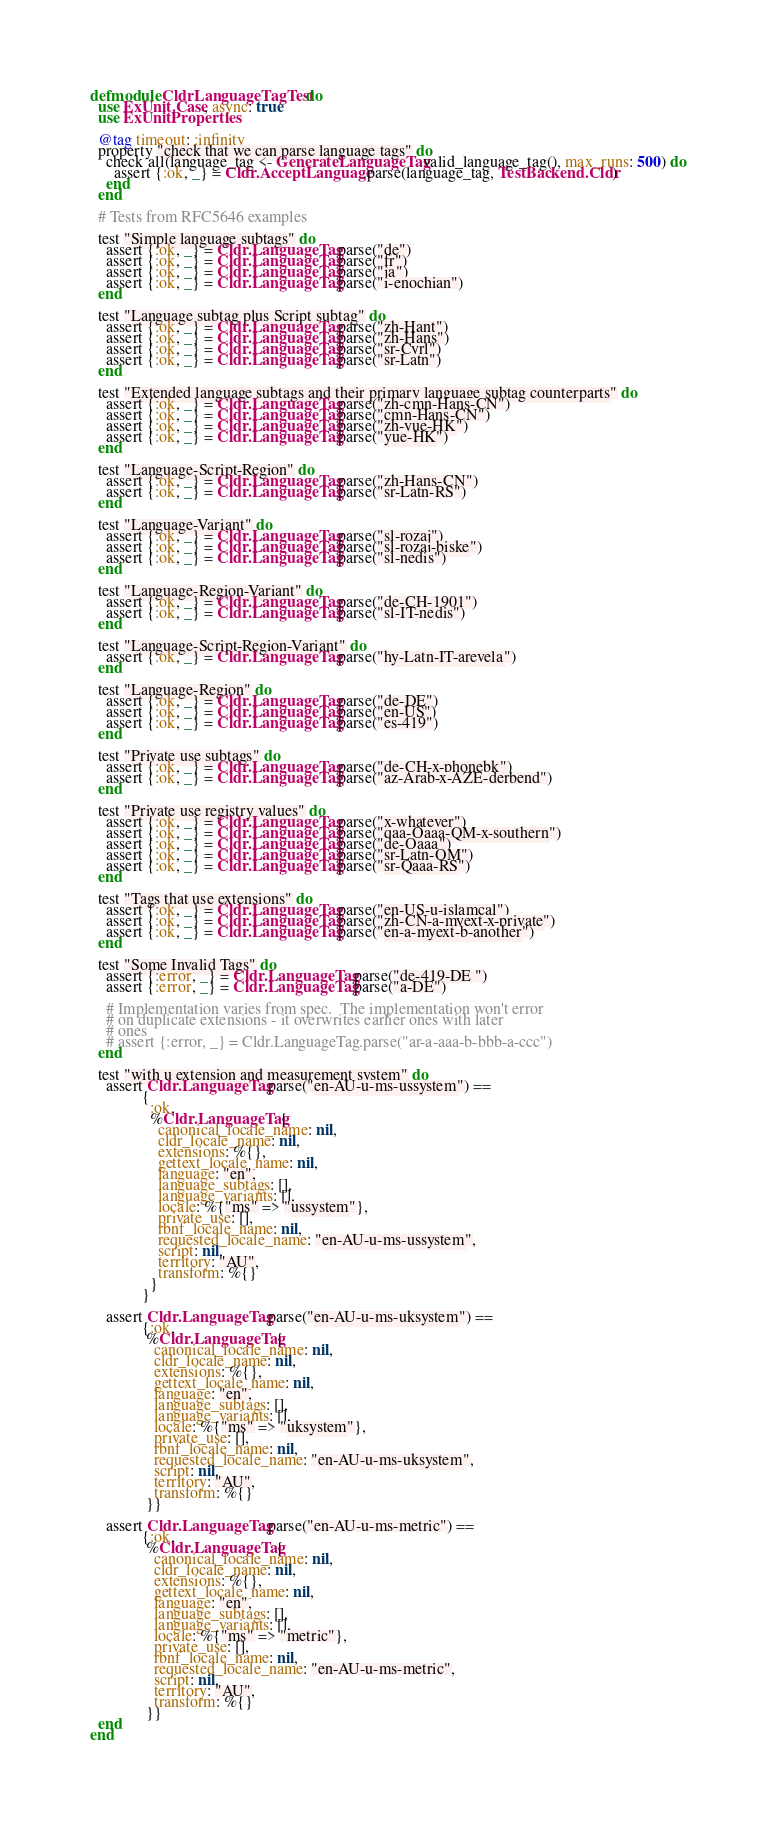<code> <loc_0><loc_0><loc_500><loc_500><_Elixir_>defmodule CldrLanguageTagTest do
  use ExUnit.Case, async: true
  use ExUnitProperties

  @tag timeout: :infinity
  property "check that we can parse language tags" do
    check all(language_tag <- GenerateLanguageTag.valid_language_tag(), max_runs: 500) do
      assert {:ok, _} = Cldr.AcceptLanguage.parse(language_tag, TestBackend.Cldr)
    end
  end

  # Tests from RFC5646 examples

  test "Simple language subtags" do
    assert {:ok, _} = Cldr.LanguageTag.parse("de")
    assert {:ok, _} = Cldr.LanguageTag.parse("fr")
    assert {:ok, _} = Cldr.LanguageTag.parse("ja")
    assert {:ok, _} = Cldr.LanguageTag.parse("i-enochian")
  end

  test "Language subtag plus Script subtag" do
    assert {:ok, _} = Cldr.LanguageTag.parse("zh-Hant")
    assert {:ok, _} = Cldr.LanguageTag.parse("zh-Hans")
    assert {:ok, _} = Cldr.LanguageTag.parse("sr-Cyrl")
    assert {:ok, _} = Cldr.LanguageTag.parse("sr-Latn")
  end

  test "Extended language subtags and their primary language subtag counterparts" do
    assert {:ok, _} = Cldr.LanguageTag.parse("zh-cmn-Hans-CN")
    assert {:ok, _} = Cldr.LanguageTag.parse("cmn-Hans-CN")
    assert {:ok, _} = Cldr.LanguageTag.parse("zh-yue-HK")
    assert {:ok, _} = Cldr.LanguageTag.parse("yue-HK")
  end

  test "Language-Script-Region" do
    assert {:ok, _} = Cldr.LanguageTag.parse("zh-Hans-CN")
    assert {:ok, _} = Cldr.LanguageTag.parse("sr-Latn-RS")
  end

  test "Language-Variant" do
    assert {:ok, _} = Cldr.LanguageTag.parse("sl-rozaj")
    assert {:ok, _} = Cldr.LanguageTag.parse("sl-rozaj-biske")
    assert {:ok, _} = Cldr.LanguageTag.parse("sl-nedis")
  end

  test "Language-Region-Variant" do
    assert {:ok, _} = Cldr.LanguageTag.parse("de-CH-1901")
    assert {:ok, _} = Cldr.LanguageTag.parse("sl-IT-nedis")
  end

  test "Language-Script-Region-Variant" do
    assert {:ok, _} = Cldr.LanguageTag.parse("hy-Latn-IT-arevela")
  end

  test "Language-Region" do
    assert {:ok, _} = Cldr.LanguageTag.parse("de-DE")
    assert {:ok, _} = Cldr.LanguageTag.parse("en-US")
    assert {:ok, _} = Cldr.LanguageTag.parse("es-419")
  end

  test "Private use subtags" do
    assert {:ok, _} = Cldr.LanguageTag.parse("de-CH-x-phonebk")
    assert {:ok, _} = Cldr.LanguageTag.parse("az-Arab-x-AZE-derbend")
  end

  test "Private use registry values" do
    assert {:ok, _} = Cldr.LanguageTag.parse("x-whatever")
    assert {:ok, _} = Cldr.LanguageTag.parse("qaa-Qaaa-QM-x-southern")
    assert {:ok, _} = Cldr.LanguageTag.parse("de-Qaaa")
    assert {:ok, _} = Cldr.LanguageTag.parse("sr-Latn-QM")
    assert {:ok, _} = Cldr.LanguageTag.parse("sr-Qaaa-RS")
  end

  test "Tags that use extensions" do
    assert {:ok, _} = Cldr.LanguageTag.parse("en-US-u-islamcal")
    assert {:ok, _} = Cldr.LanguageTag.parse("zh-CN-a-myext-x-private")
    assert {:ok, _} = Cldr.LanguageTag.parse("en-a-myext-b-another")
  end

  test "Some Invalid Tags" do
    assert {:error, _} = Cldr.LanguageTag.parse("de-419-DE ")
    assert {:error, _} = Cldr.LanguageTag.parse("a-DE")

    # Implementation varies from spec.  The implementation won't error
    # on duplicate extensions - it overwrites earlier ones with later
    # ones
    # assert {:error, _} = Cldr.LanguageTag.parse("ar-a-aaa-b-bbb-a-ccc")
  end

  test "with u extension and measurement system" do
    assert Cldr.LanguageTag.parse("en-AU-u-ms-ussystem") ==
             {
               :ok,
               %Cldr.LanguageTag{
                 canonical_locale_name: nil,
                 cldr_locale_name: nil,
                 extensions: %{},
                 gettext_locale_name: nil,
                 language: "en",
                 language_subtags: [],
                 language_variants: [],
                 locale: %{"ms" => "ussystem"},
                 private_use: [],
                 rbnf_locale_name: nil,
                 requested_locale_name: "en-AU-u-ms-ussystem",
                 script: nil,
                 territory: "AU",
                 transform: %{}
               }
             }

    assert Cldr.LanguageTag.parse("en-AU-u-ms-uksystem") ==
             {:ok,
              %Cldr.LanguageTag{
                canonical_locale_name: nil,
                cldr_locale_name: nil,
                extensions: %{},
                gettext_locale_name: nil,
                language: "en",
                language_subtags: [],
                language_variants: [],
                locale: %{"ms" => "uksystem"},
                private_use: [],
                rbnf_locale_name: nil,
                requested_locale_name: "en-AU-u-ms-uksystem",
                script: nil,
                territory: "AU",
                transform: %{}
              }}

    assert Cldr.LanguageTag.parse("en-AU-u-ms-metric") ==
             {:ok,
              %Cldr.LanguageTag{
                canonical_locale_name: nil,
                cldr_locale_name: nil,
                extensions: %{},
                gettext_locale_name: nil,
                language: "en",
                language_subtags: [],
                language_variants: [],
                locale: %{"ms" => "metric"},
                private_use: [],
                rbnf_locale_name: nil,
                requested_locale_name: "en-AU-u-ms-metric",
                script: nil,
                territory: "AU",
                transform: %{}
              }}
  end
end
</code> 